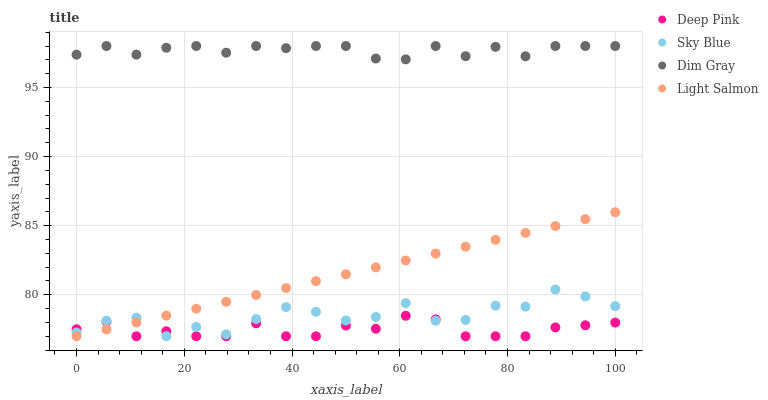Does Deep Pink have the minimum area under the curve?
Answer yes or no. Yes. Does Dim Gray have the maximum area under the curve?
Answer yes or no. Yes. Does Dim Gray have the minimum area under the curve?
Answer yes or no. No. Does Deep Pink have the maximum area under the curve?
Answer yes or no. No. Is Light Salmon the smoothest?
Answer yes or no. Yes. Is Sky Blue the roughest?
Answer yes or no. Yes. Is Dim Gray the smoothest?
Answer yes or no. No. Is Dim Gray the roughest?
Answer yes or no. No. Does Sky Blue have the lowest value?
Answer yes or no. Yes. Does Dim Gray have the lowest value?
Answer yes or no. No. Does Dim Gray have the highest value?
Answer yes or no. Yes. Does Deep Pink have the highest value?
Answer yes or no. No. Is Light Salmon less than Dim Gray?
Answer yes or no. Yes. Is Dim Gray greater than Sky Blue?
Answer yes or no. Yes. Does Sky Blue intersect Light Salmon?
Answer yes or no. Yes. Is Sky Blue less than Light Salmon?
Answer yes or no. No. Is Sky Blue greater than Light Salmon?
Answer yes or no. No. Does Light Salmon intersect Dim Gray?
Answer yes or no. No. 